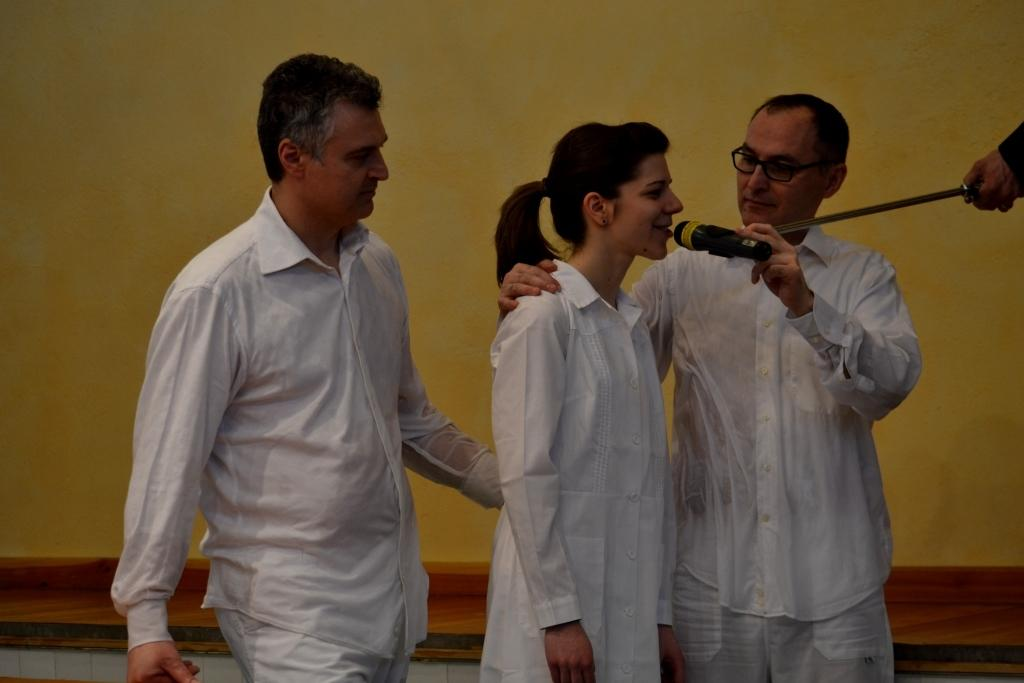How many people are in the image? There are two men and a woman in the image, making a total of three people. What is one of the men doing in the image? One of the men is holding a microphone. What color are the clothes worn by the people in the image? The people in the image are wearing white clothes. Is there any quicksand visible in the image? No, there is no quicksand present in the image. How many elbows can be seen in the image? The number of elbows visible in the image cannot be determined without more information about the people's positions and gestures. 